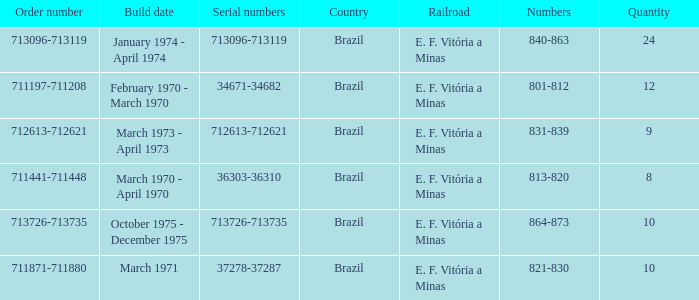The serial numbers 713096-713119 are in which country? Brazil. 